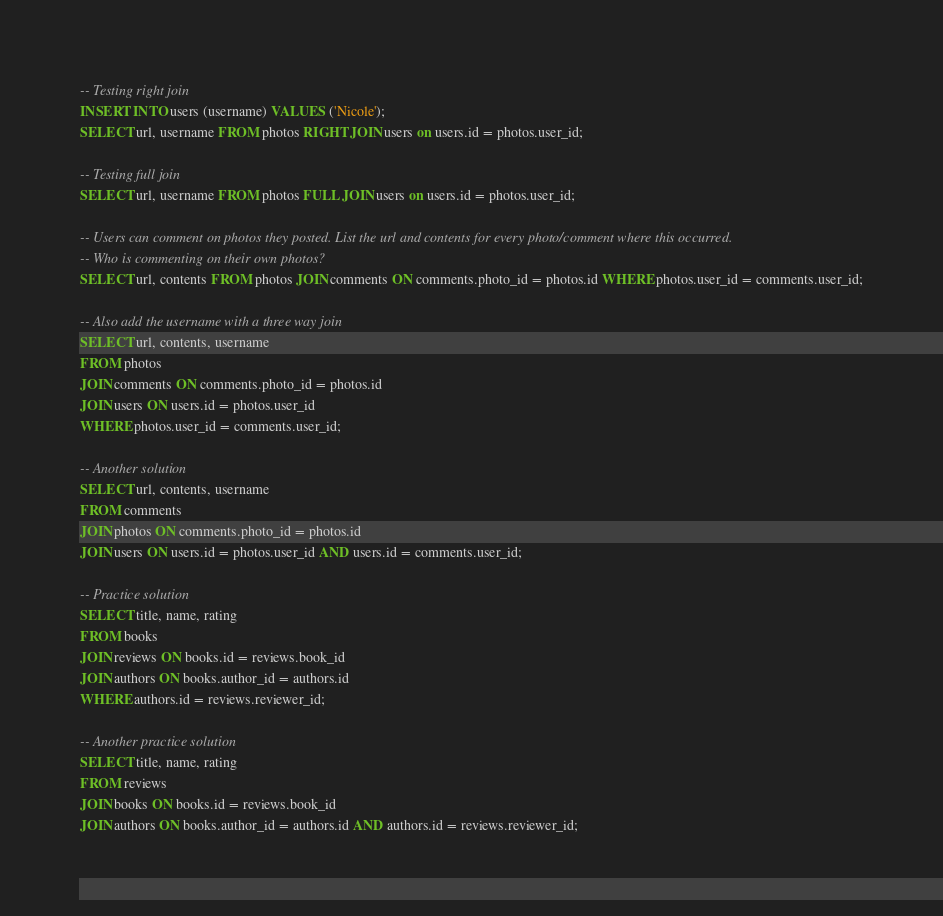<code> <loc_0><loc_0><loc_500><loc_500><_SQL_>-- Testing right join
INSERT INTO users (username) VALUES ('Nicole');
SELECT url, username FROM photos RIGHT JOIN users on users.id = photos.user_id;

-- Testing full join
SELECT url, username FROM photos FULL JOIN users on users.id = photos.user_id;

-- Users can comment on photos they posted. List the url and contents for every photo/comment where this occurred.
-- Who is commenting on their own photos?
SELECT url, contents FROM photos JOIN comments ON comments.photo_id = photos.id WHERE photos.user_id = comments.user_id;

-- Also add the username with a three way join
SELECT url, contents, username
FROM photos
JOIN comments ON comments.photo_id = photos.id
JOIN users ON users.id = photos.user_id
WHERE photos.user_id = comments.user_id;

-- Another solution
SELECT url, contents, username
FROM comments
JOIN photos ON comments.photo_id = photos.id
JOIN users ON users.id = photos.user_id AND users.id = comments.user_id;

-- Practice solution
SELECT title, name, rating
FROM books
JOIN reviews ON books.id = reviews.book_id
JOIN authors ON books.author_id = authors.id
WHERE authors.id = reviews.reviewer_id;

-- Another practice solution
SELECT title, name, rating
FROM reviews
JOIN books ON books.id = reviews.book_id
JOIN authors ON books.author_id = authors.id AND authors.id = reviews.reviewer_id;
</code> 